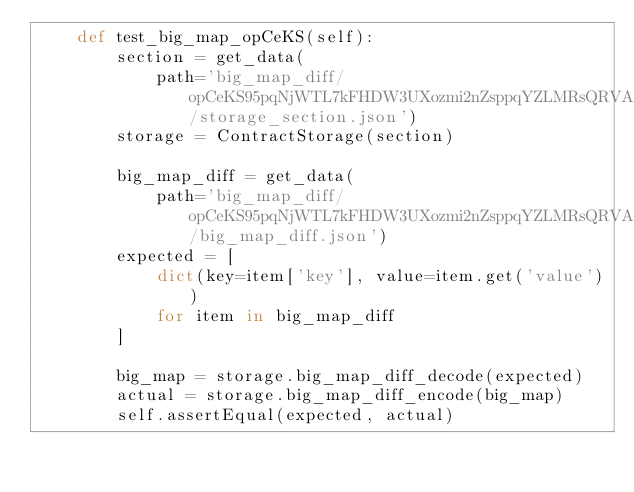<code> <loc_0><loc_0><loc_500><loc_500><_Python_>    def test_big_map_opCeKS(self):    
        section = get_data(
            path='big_map_diff/opCeKS95pqNjWTL7kFHDW3UXozmi2nZsppqYZLMRsQRVAZYu8hW/storage_section.json')
        storage = ContractStorage(section)
            
        big_map_diff = get_data(
            path='big_map_diff/opCeKS95pqNjWTL7kFHDW3UXozmi2nZsppqYZLMRsQRVAZYu8hW/big_map_diff.json')
        expected = [
            dict(key=item['key'], value=item.get('value'))
            for item in big_map_diff
        ]
        
        big_map = storage.big_map_diff_decode(expected)
        actual = storage.big_map_diff_encode(big_map)
        self.assertEqual(expected, actual)
</code> 